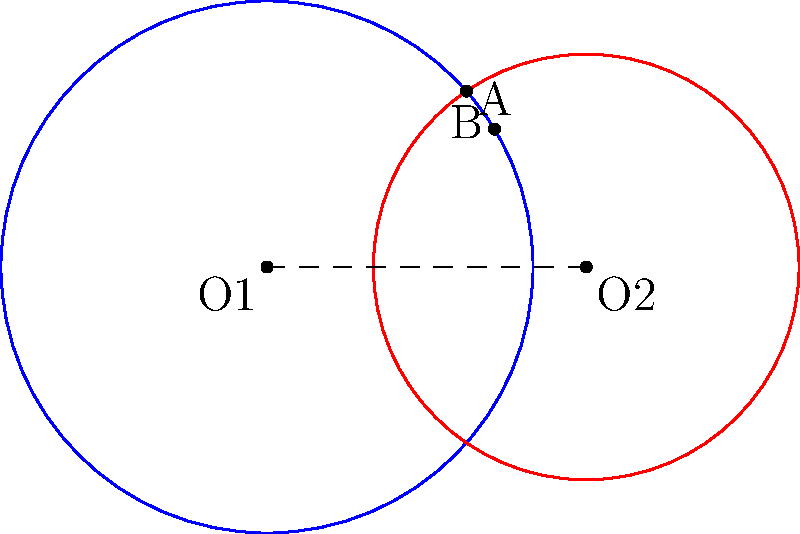Two species of bees, A and B, have circular foraging ranges with radii of 5 km and 4 km respectively. The centers of their foraging areas are 6 km apart. Calculate the area of the region where their foraging ranges overlap, representing potential competition for resources. Round your answer to the nearest 0.01 km². To find the area of overlap between two circles, we need to use the formula for the area of intersection of two circles. Let's approach this step-by-step:

1) First, we need to find the distance between the centers of the circles (d):
   $d = 6$ km (given in the problem)

2) Now, we need to calculate the angle θ (in radians) for each circle:
   For circle A: $\theta_1 = 2 \arccos(\frac{d^2 + r_1^2 - r_2^2}{2dr_1})$
   For circle B: $\theta_2 = 2 \arccos(\frac{d^2 + r_2^2 - r_1^2}{2dr_2})$

   $\theta_1 = 2 \arccos(\frac{6^2 + 5^2 - 4^2}{2 \cdot 6 \cdot 5}) = 2.2143$ radians
   $\theta_2 = 2 \arccos(\frac{6^2 + 4^2 - 5^2}{2 \cdot 6 \cdot 4}) = 2.7925$ radians

3) The area of the lens-shaped overlap is given by:
   $A = \frac{1}{2}r_1^2(\theta_1 - \sin\theta_1) + \frac{1}{2}r_2^2(\theta_2 - \sin\theta_2)$

4) Substituting the values:
   $A = \frac{1}{2}(5^2)(2.2143 - \sin(2.2143)) + \frac{1}{2}(4^2)(2.7925 - \sin(2.7925))$
   $A = 12.5(2.2143 - 0.8109) + 8(2.7925 - 0.9715)$
   $A = 17.5425 + 14.5680$
   $A = 32.1105$ km²

5) Rounding to the nearest 0.01 km²:
   $A ≈ 32.11$ km²
Answer: 32.11 km² 